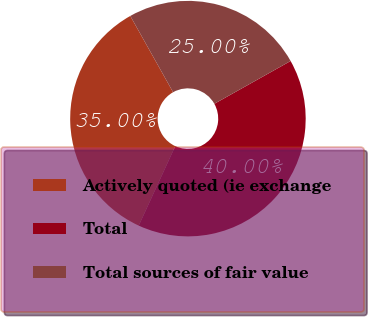Convert chart to OTSL. <chart><loc_0><loc_0><loc_500><loc_500><pie_chart><fcel>Actively quoted (ie exchange<fcel>Total<fcel>Total sources of fair value<nl><fcel>35.0%<fcel>40.0%<fcel>25.0%<nl></chart> 